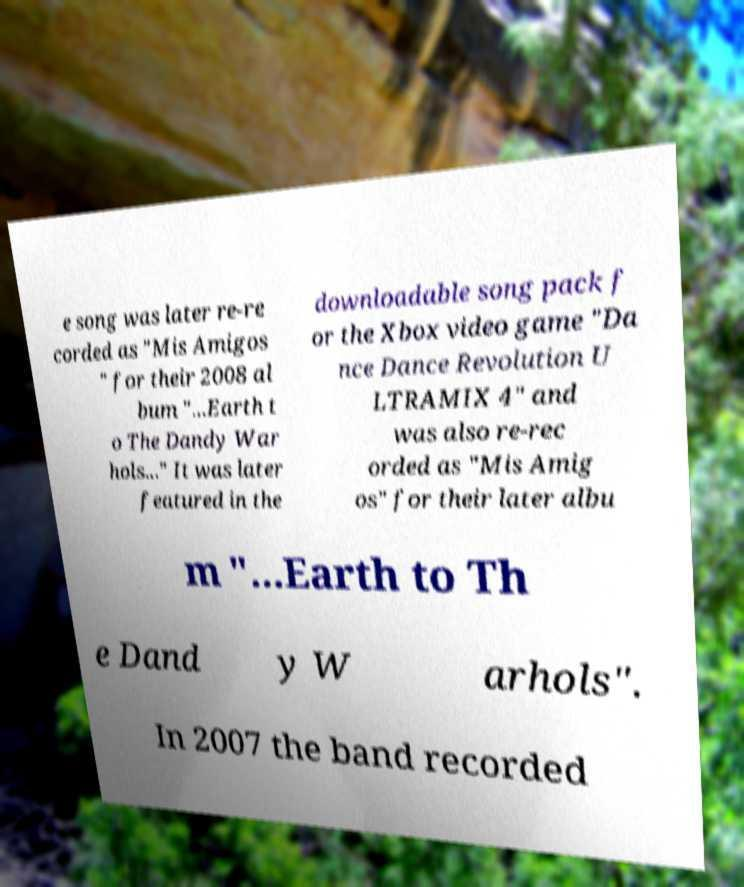For documentation purposes, I need the text within this image transcribed. Could you provide that? e song was later re-re corded as "Mis Amigos " for their 2008 al bum "...Earth t o The Dandy War hols..." It was later featured in the downloadable song pack f or the Xbox video game "Da nce Dance Revolution U LTRAMIX 4" and was also re-rec orded as "Mis Amig os" for their later albu m "...Earth to Th e Dand y W arhols". In 2007 the band recorded 